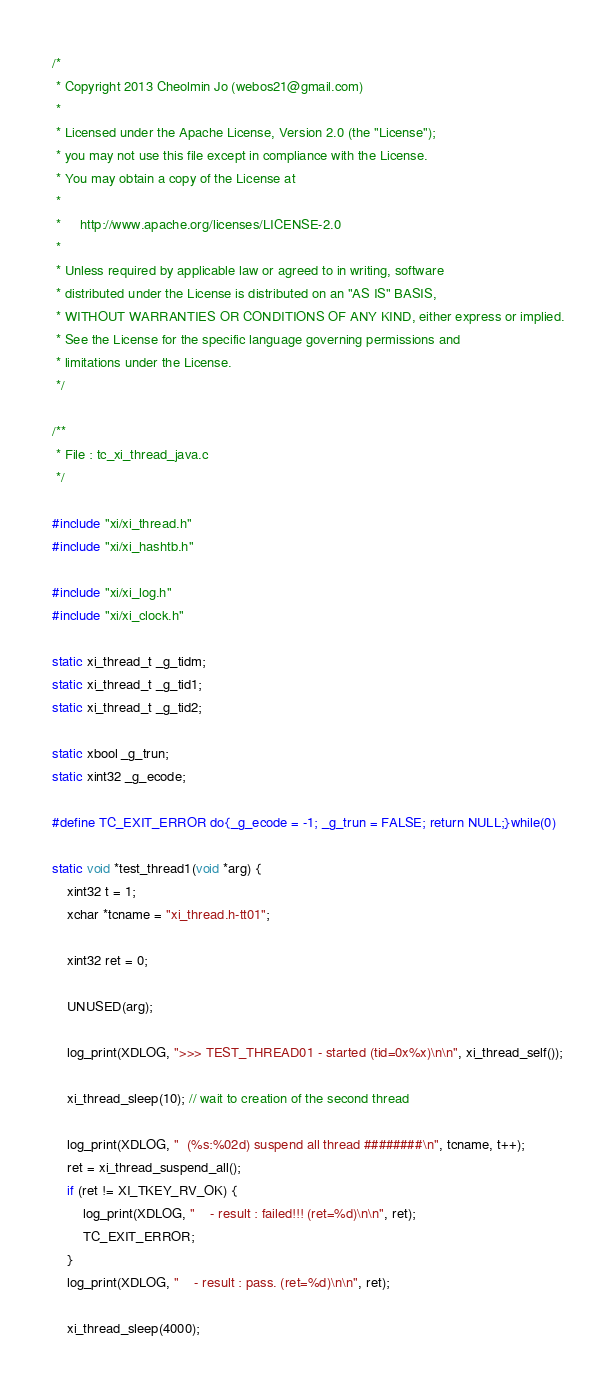<code> <loc_0><loc_0><loc_500><loc_500><_C_>/*
 * Copyright 2013 Cheolmin Jo (webos21@gmail.com)
 *
 * Licensed under the Apache License, Version 2.0 (the "License");
 * you may not use this file except in compliance with the License.
 * You may obtain a copy of the License at
 *
 *     http://www.apache.org/licenses/LICENSE-2.0
 *
 * Unless required by applicable law or agreed to in writing, software
 * distributed under the License is distributed on an "AS IS" BASIS,
 * WITHOUT WARRANTIES OR CONDITIONS OF ANY KIND, either express or implied.
 * See the License for the specific language governing permissions and
 * limitations under the License.
 */

/**
 * File : tc_xi_thread_java.c
 */

#include "xi/xi_thread.h"
#include "xi/xi_hashtb.h"

#include "xi/xi_log.h"
#include "xi/xi_clock.h"

static xi_thread_t _g_tidm;
static xi_thread_t _g_tid1;
static xi_thread_t _g_tid2;

static xbool _g_trun;
static xint32 _g_ecode;

#define TC_EXIT_ERROR do{_g_ecode = -1; _g_trun = FALSE; return NULL;}while(0)

static void *test_thread1(void *arg) {
	xint32 t = 1;
	xchar *tcname = "xi_thread.h-tt01";

	xint32 ret = 0;

	UNUSED(arg);

	log_print(XDLOG, ">>> TEST_THREAD01 - started (tid=0x%x)\n\n", xi_thread_self());

	xi_thread_sleep(10); // wait to creation of the second thread

	log_print(XDLOG, "  (%s:%02d) suspend all thread ########\n", tcname, t++);
	ret = xi_thread_suspend_all();
	if (ret != XI_TKEY_RV_OK) {
		log_print(XDLOG, "    - result : failed!!! (ret=%d)\n\n", ret);
		TC_EXIT_ERROR;
	}
	log_print(XDLOG, "    - result : pass. (ret=%d)\n\n", ret);

	xi_thread_sleep(4000);
</code> 